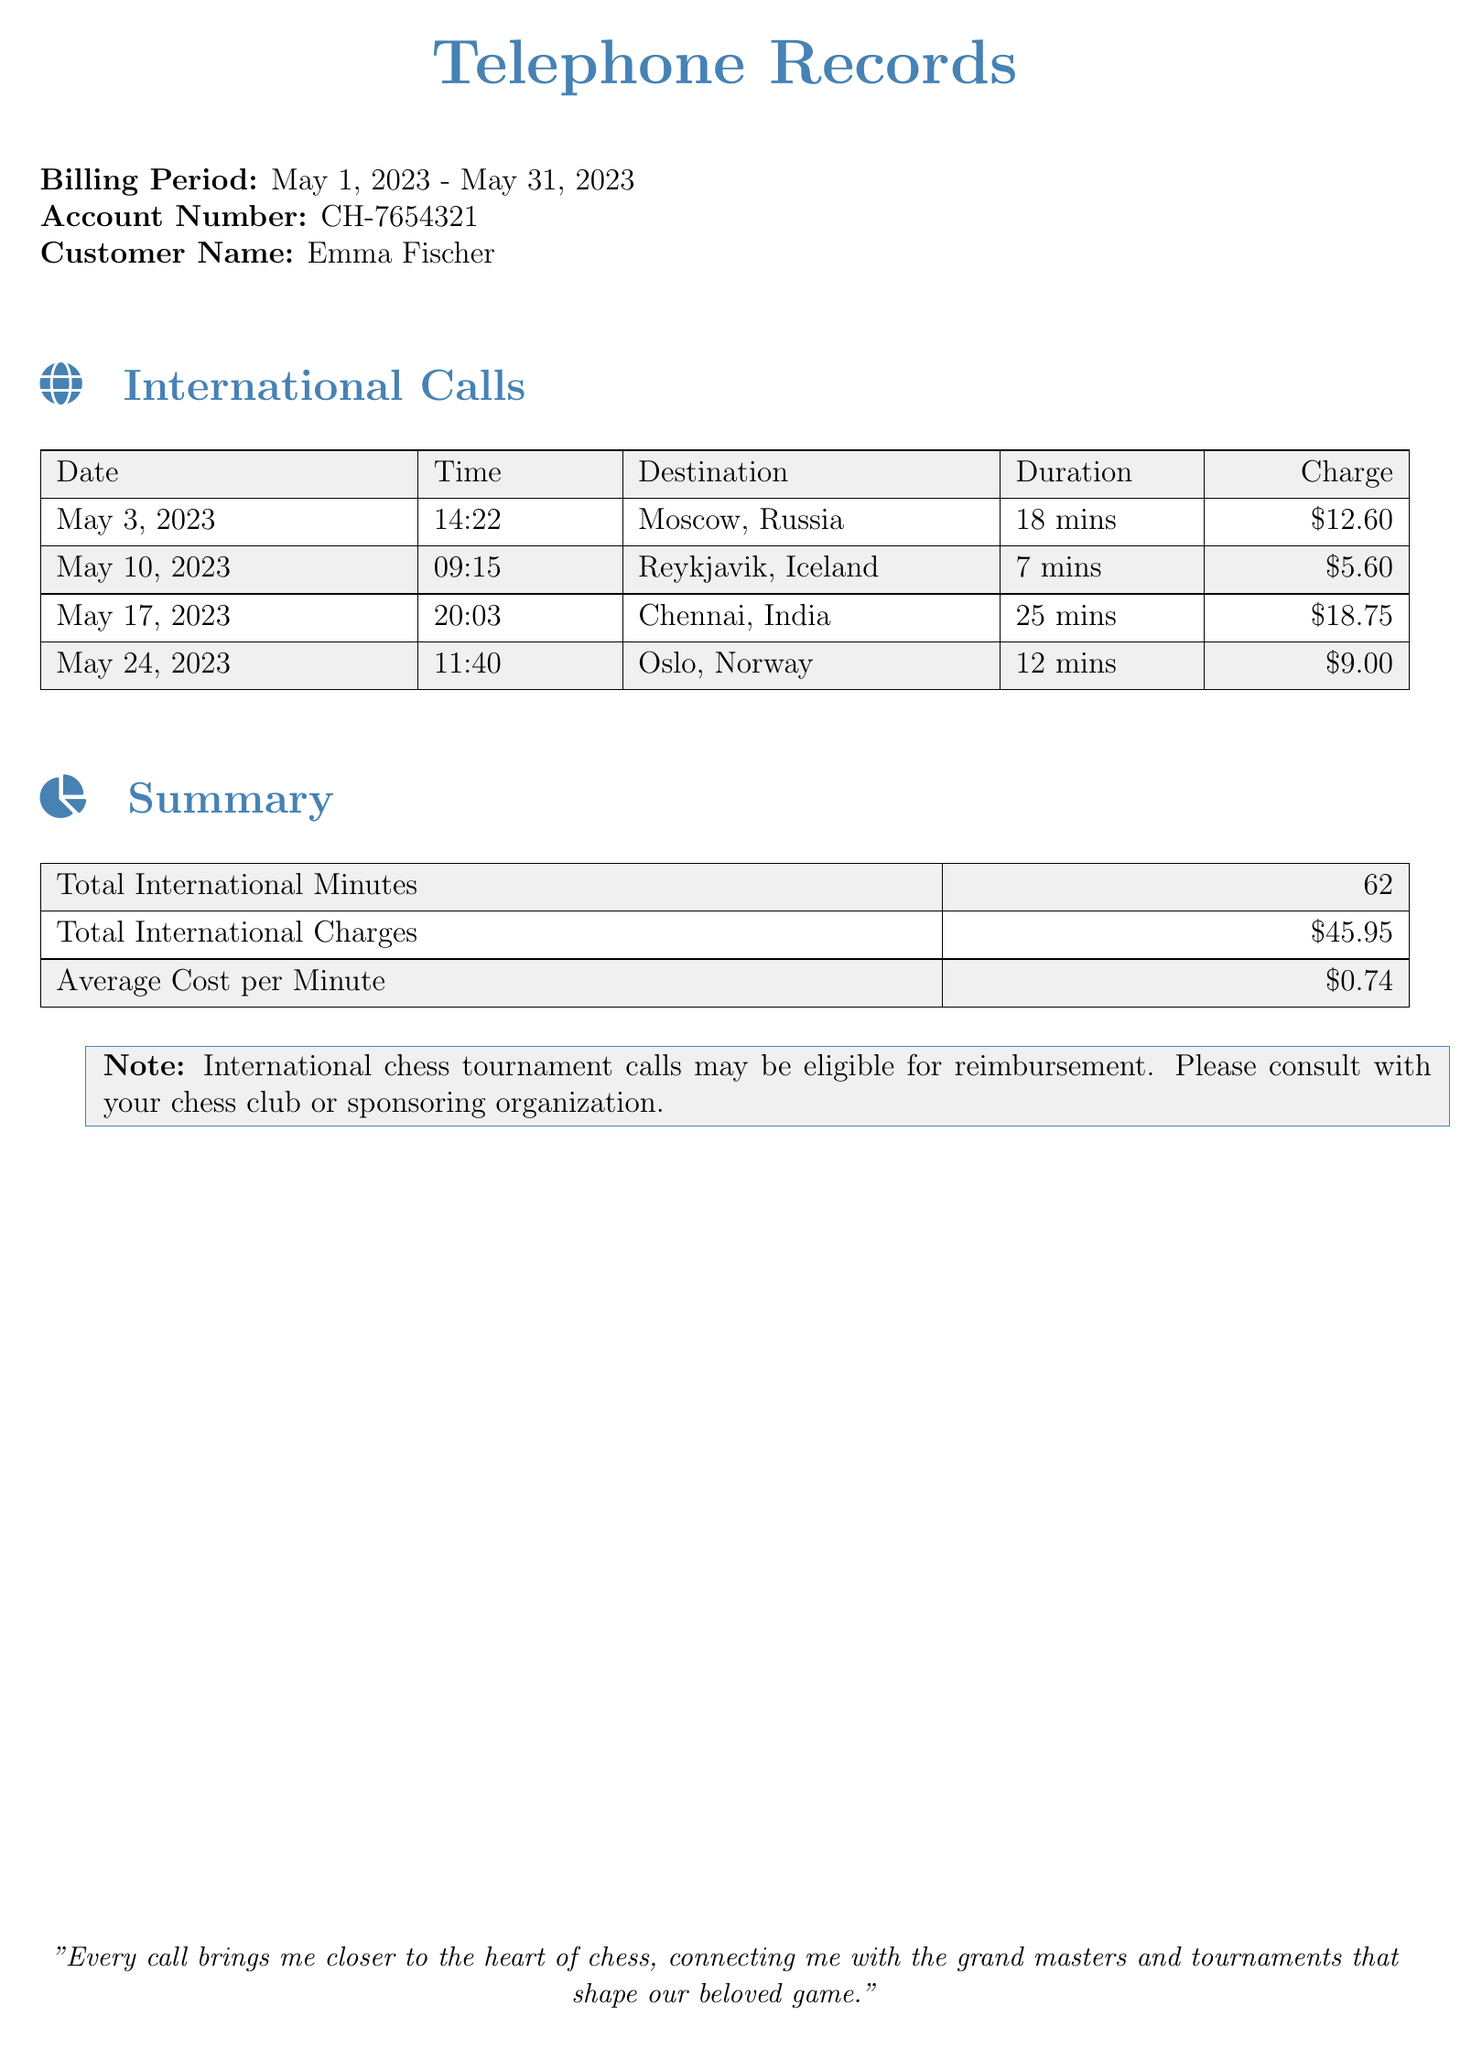What is the billing period? The billing period is identified in the document as May 1, 2023 - May 31, 2023.
Answer: May 1, 2023 - May 31, 2023 How many minutes were spent on international calls? The total international minutes are provided in the summary section of the document, which totals 62 minutes.
Answer: 62 What is the charge for the call to Chennai, India? The document specifies that the charge for the call to Chennai, India, is $18.75.
Answer: $18.75 Which destination had the least duration for a call? The Reykjavik, Iceland call duration is the shortest at 7 minutes.
Answer: Reykjavik, Iceland What is the average cost per minute for international calls? The average cost per minute is calculated from the total charges and total minutes provided in the summary. It is given as $0.74.
Answer: $0.74 How many calls were listed in the document? By counting the individual entries under international calls in the table, three calls can be identified.
Answer: 4 What is the total charge for international calls? The total international charges sum up to $45.95, as stated in the summary section.
Answer: $45.95 What date was the call to Moscow placed? The specific date when the call to Moscow was made is listed as May 3, 2023.
Answer: May 3, 2023 What note is provided about the calls? There is a note about the possibility of reimbursement for international chess tournament calls, which suggests consulting the chess club or organization.
Answer: International chess tournament calls may be eligible for reimbursement 